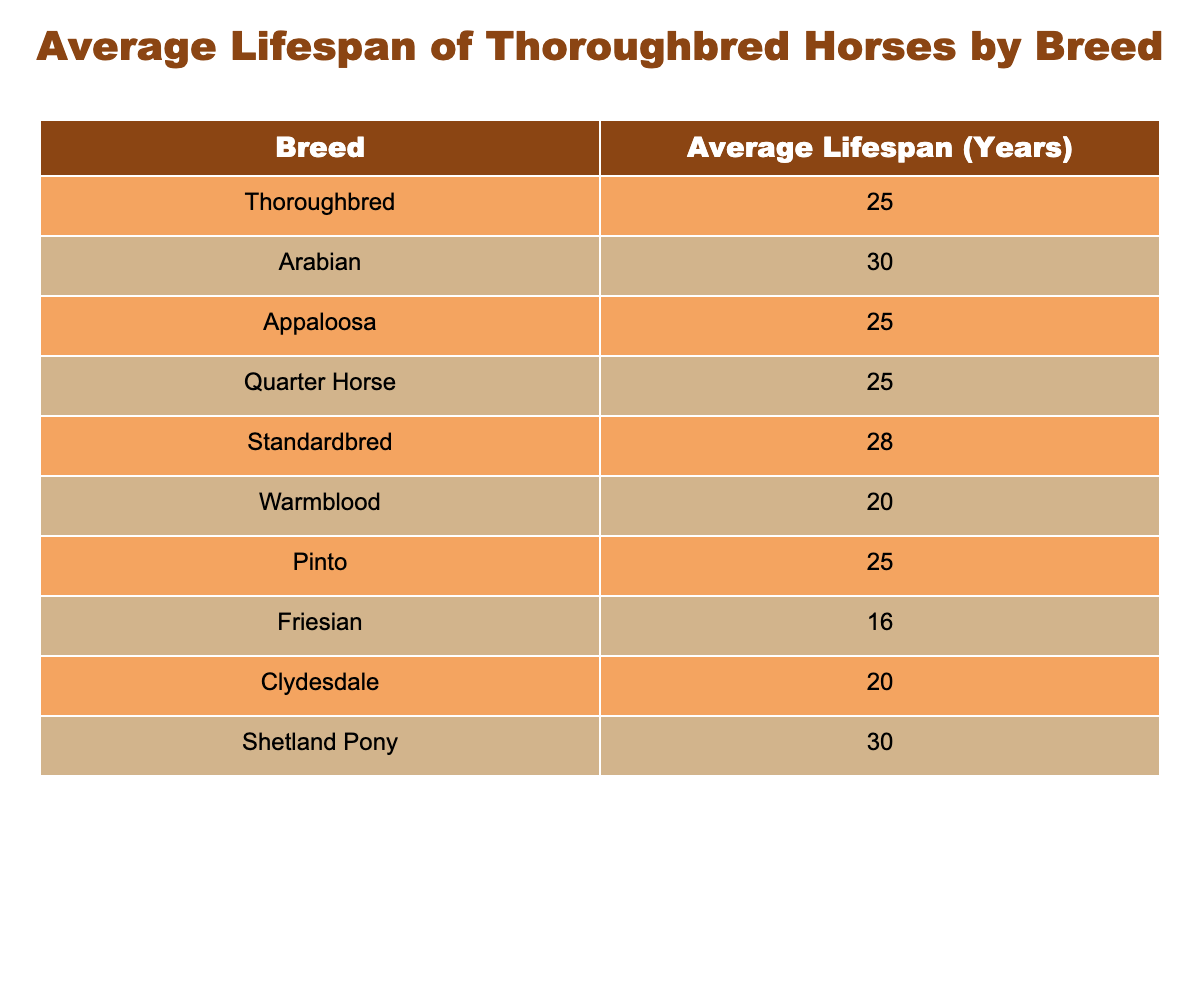What is the average lifespan of a Thoroughbred? The table states that the average lifespan of a Thoroughbred horse is 25 years.
Answer: 25 years Which breed has the longest lifespan? According to the table, the breed with the longest lifespan is the Arabian horse, with an average lifespan of 30 years.
Answer: Arabian with 30 years Are there any breeds with the same average lifespan as the Thoroughbred? By reviewing the table, the Appaloosa, Quarter Horse, and Pinto all have an average lifespan of 25 years, which matches that of the Thoroughbred.
Answer: Yes, Appaloosa, Quarter Horse, Pinto What is the difference in average lifespan between the Friesian and the Arabian breeds? The average lifespan of a Friesian is 16 years and the Arabian is 30 years. Subtracting these values gives 30 - 16 = 14 years.
Answer: 14 years How many breeds have an average lifespan greater than 25 years? The table shows that only two breeds have an average lifespan greater than 25 years: the Arabian (30 years) and the Shetland Pony (30 years). Since there are two, the answer is 2.
Answer: 2 breeds Is it true that Warmblood horses live longer on average than Friesian horses? The table indicates that Warmblood horses have an average lifespan of 20 years, while Friesians live an average of 16 years. Thus, it is true that Warmbloods live longer.
Answer: Yes What is the average lifespan of the Clydesdale and Standardbred breeds combined? The average lifespan of Clydesdales is 20 years, and Standardbreds is 28 years. Adding these gives a total of 20 + 28 = 48 years. To find the average, divide by 2, giving 48 / 2 = 24 years.
Answer: 24 years Which breed has the shortest lifespan, and what is it? The table states that the Friesian breed has the shortest lifespan, which is 16 years.
Answer: Friesian with 16 years What is the middle lifespan if you were to list all the average lifespans in ascending order? Listing the lifespans: 16 (Friesian), 20 (Warmblood, Clydesdale), 25 (Thoroughbred, Appaloosa, Quarter Horse, Pinto), 28 (Standardbred), 30 (Arabian, Shetland Pony). With 10 total entries, the median will be the average of the 5th and 6th numbers (both are 25), resulting in (25 + 25) / 2 = 25.
Answer: 25 years 